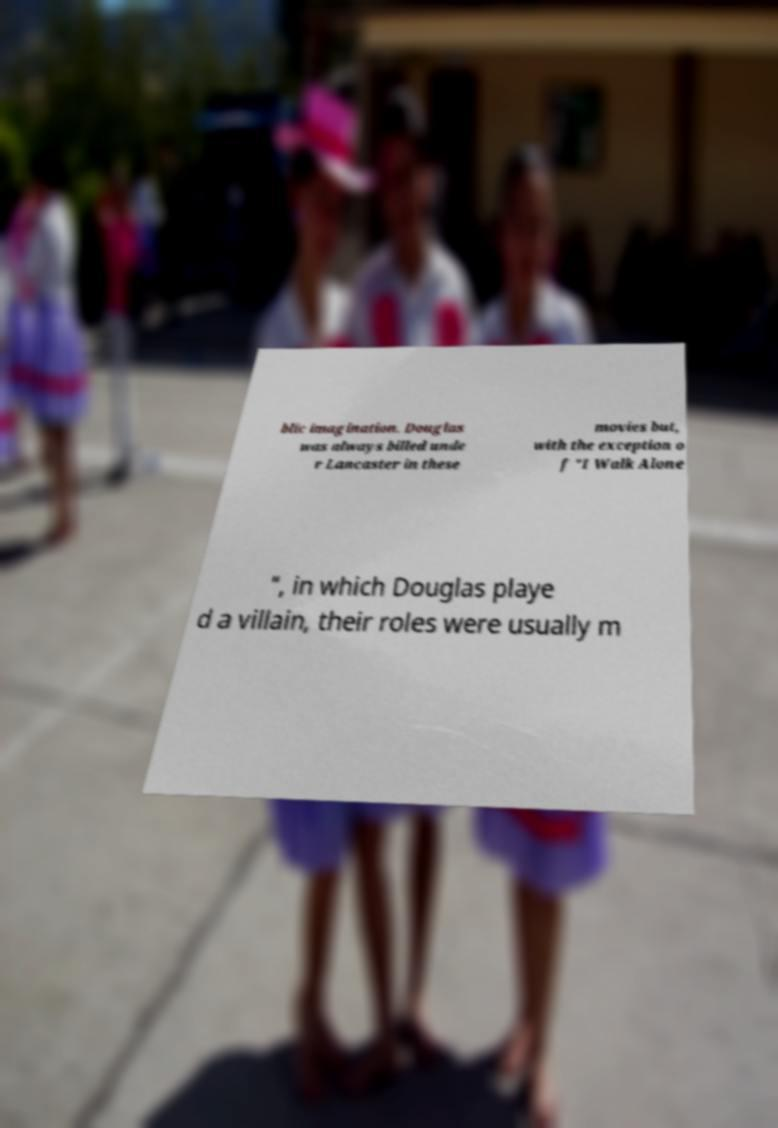Please identify and transcribe the text found in this image. blic imagination. Douglas was always billed unde r Lancaster in these movies but, with the exception o f "I Walk Alone ", in which Douglas playe d a villain, their roles were usually m 